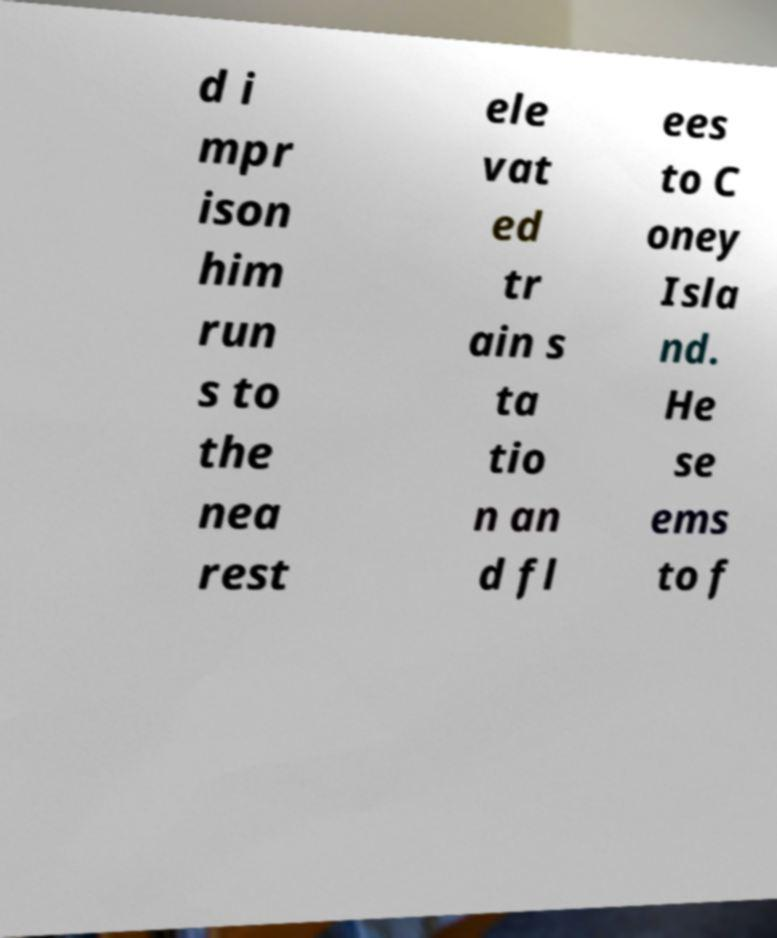Can you read and provide the text displayed in the image?This photo seems to have some interesting text. Can you extract and type it out for me? d i mpr ison him run s to the nea rest ele vat ed tr ain s ta tio n an d fl ees to C oney Isla nd. He se ems to f 